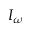<formula> <loc_0><loc_0><loc_500><loc_500>I _ { \omega }</formula> 